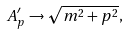Convert formula to latex. <formula><loc_0><loc_0><loc_500><loc_500>A ^ { \prime } _ { p } \to \sqrt { m ^ { 2 } + p ^ { 2 } } ,</formula> 